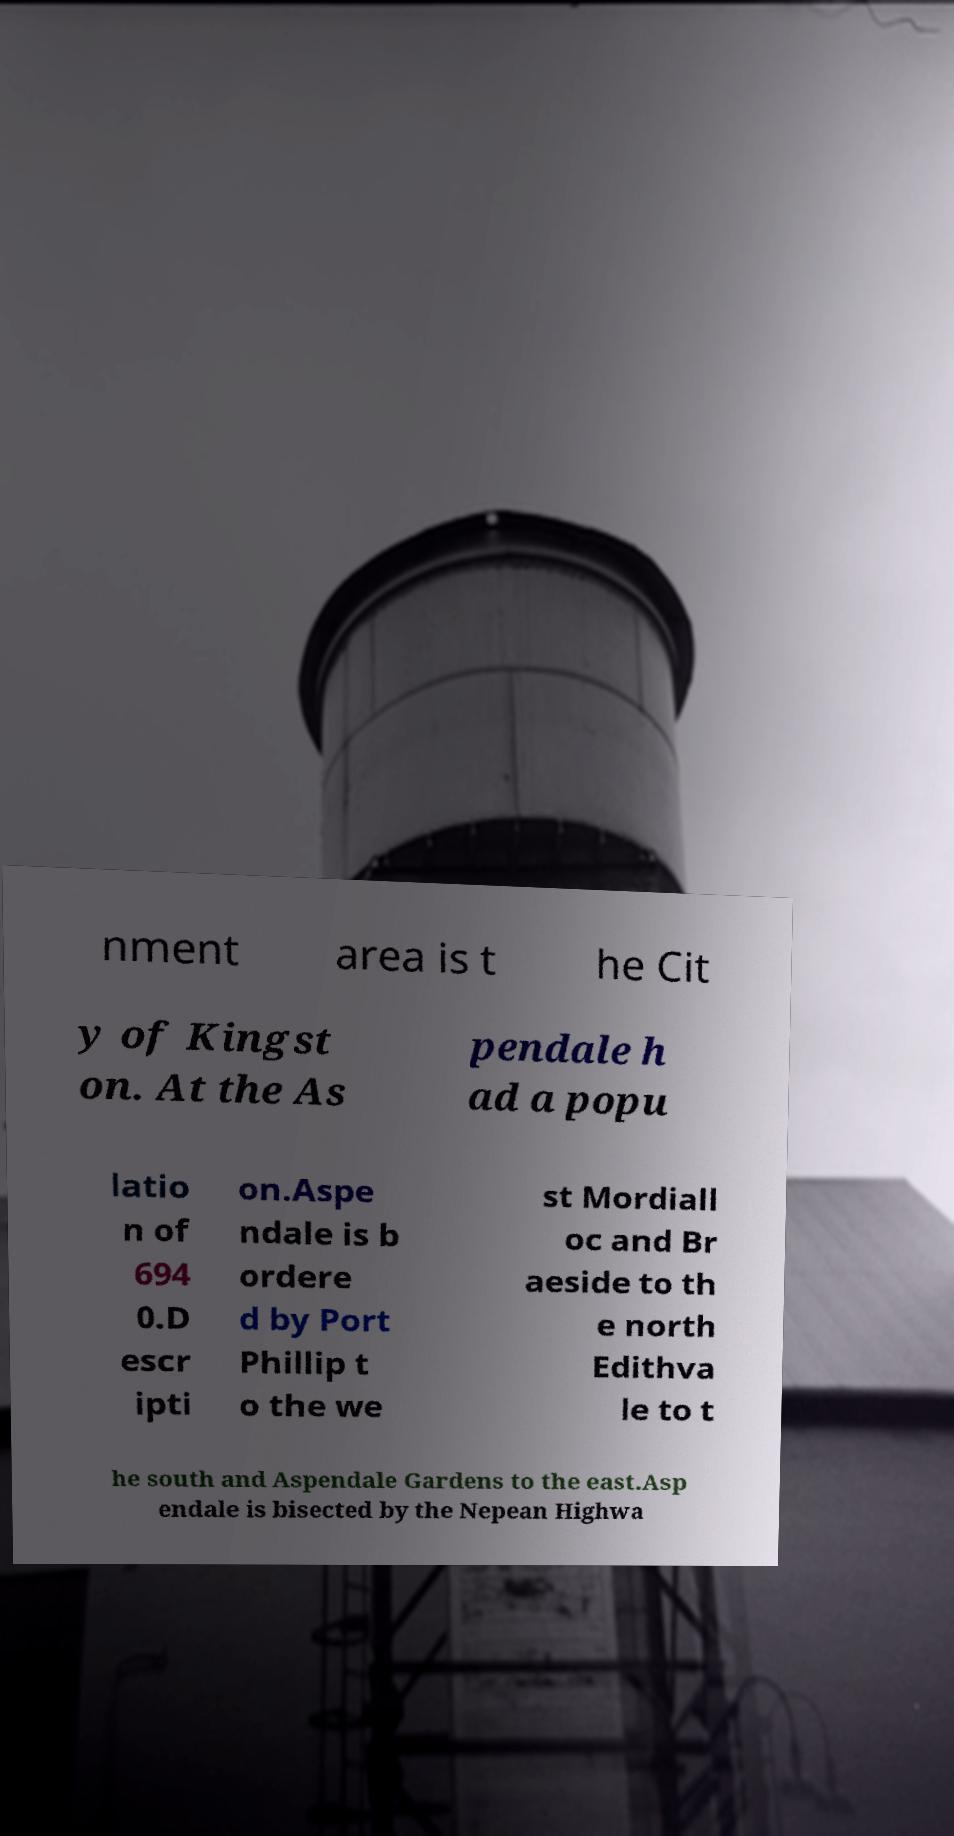What messages or text are displayed in this image? I need them in a readable, typed format. nment area is t he Cit y of Kingst on. At the As pendale h ad a popu latio n of 694 0.D escr ipti on.Aspe ndale is b ordere d by Port Phillip t o the we st Mordiall oc and Br aeside to th e north Edithva le to t he south and Aspendale Gardens to the east.Asp endale is bisected by the Nepean Highwa 